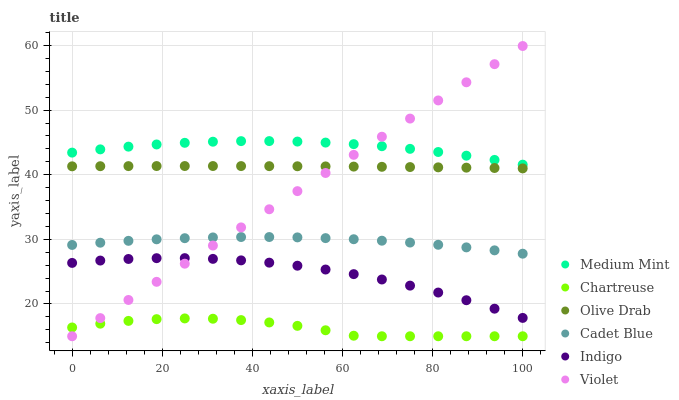Does Chartreuse have the minimum area under the curve?
Answer yes or no. Yes. Does Medium Mint have the maximum area under the curve?
Answer yes or no. Yes. Does Cadet Blue have the minimum area under the curve?
Answer yes or no. No. Does Cadet Blue have the maximum area under the curve?
Answer yes or no. No. Is Violet the smoothest?
Answer yes or no. Yes. Is Chartreuse the roughest?
Answer yes or no. Yes. Is Cadet Blue the smoothest?
Answer yes or no. No. Is Cadet Blue the roughest?
Answer yes or no. No. Does Chartreuse have the lowest value?
Answer yes or no. Yes. Does Cadet Blue have the lowest value?
Answer yes or no. No. Does Violet have the highest value?
Answer yes or no. Yes. Does Cadet Blue have the highest value?
Answer yes or no. No. Is Chartreuse less than Cadet Blue?
Answer yes or no. Yes. Is Medium Mint greater than Cadet Blue?
Answer yes or no. Yes. Does Indigo intersect Violet?
Answer yes or no. Yes. Is Indigo less than Violet?
Answer yes or no. No. Is Indigo greater than Violet?
Answer yes or no. No. Does Chartreuse intersect Cadet Blue?
Answer yes or no. No. 